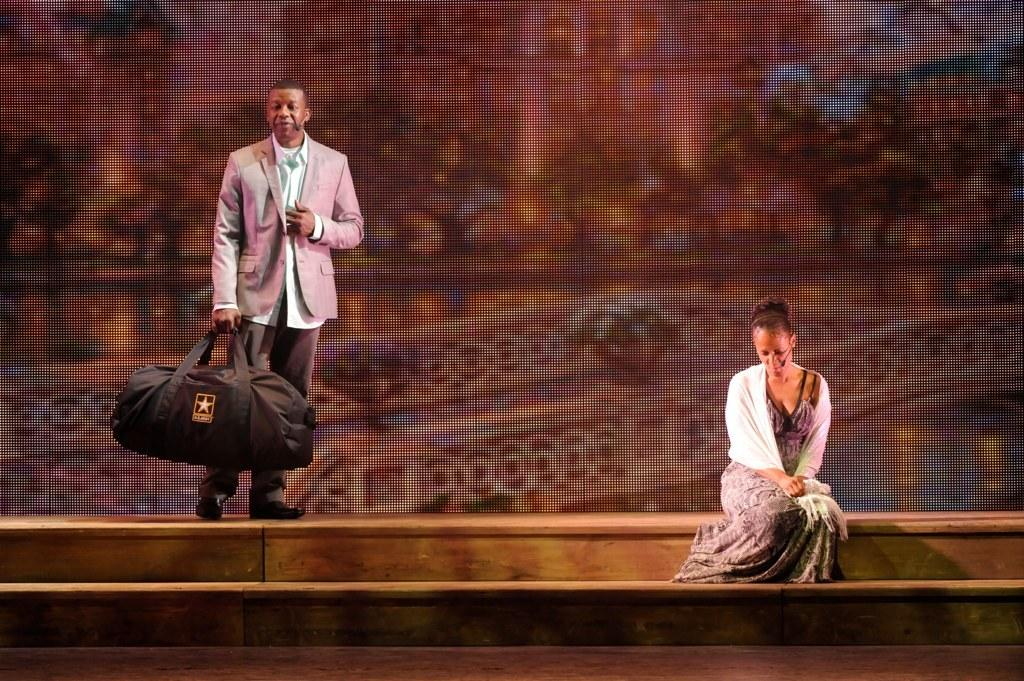How many people are in the image? There are two people in the image. What are the people doing in the image? One person is standing and holding a bag, while the other person is sitting on a step. Where are the people located in the image? The two people are on stairs. What type of drug can be seen in the image? There is no drug present in the image. How many children are visible in the image? There is no mention of children in the image, only two adults. 